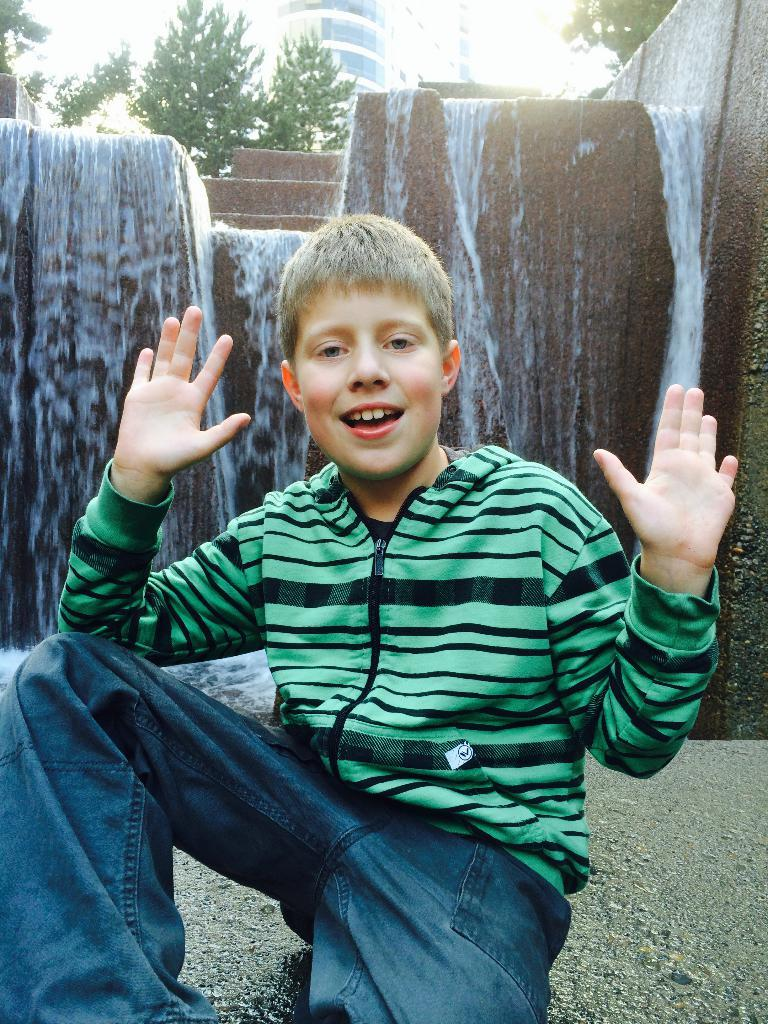What is the main subject in the foreground of the picture? There is a boy in the foreground of the picture. What natural feature is visible behind the boy? There is a waterfall behind the boy. What type of vegetation can be seen in the background of the picture? There are trees in the background of the picture. What type of structure is visible in the background of the picture? There is a building in the background of the picture. How much money is the boy holding in the picture? There is no indication in the image that the boy is holding any money, so it cannot be determined from the picture. 